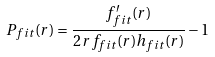<formula> <loc_0><loc_0><loc_500><loc_500>P _ { f i t } ( r ) = \frac { f _ { f i t } ^ { \prime } ( r ) } { 2 \, r f _ { f i t } ( r ) h _ { f i t } ( r ) } - 1</formula> 